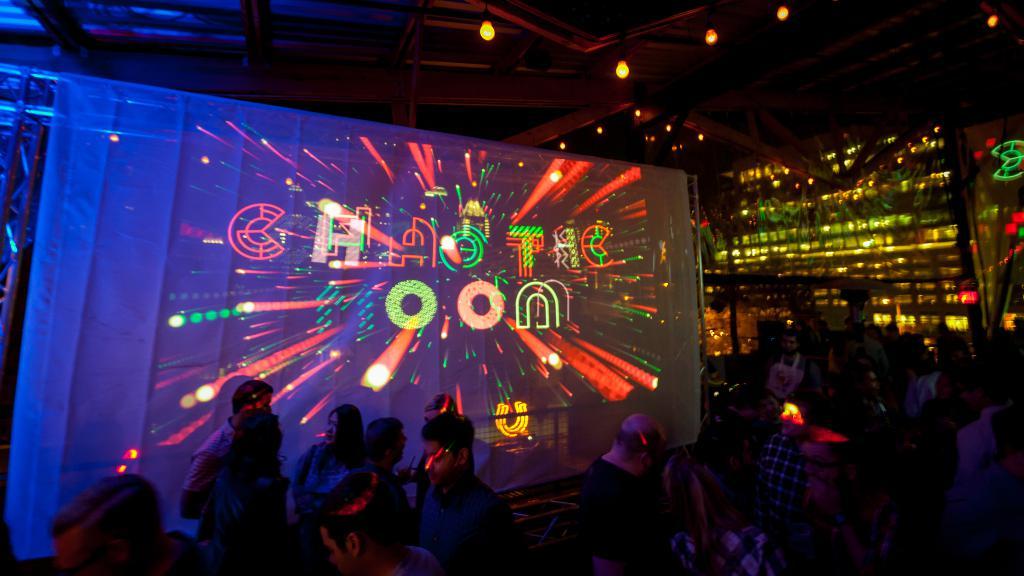What does the screen say?
Offer a terse response. Chaotic moon. What celestial body is mentioned?
Your response must be concise. Moon. 